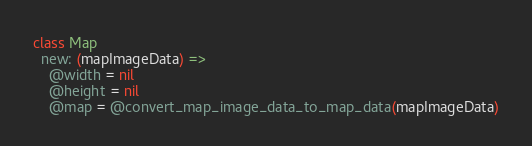Convert code to text. <code><loc_0><loc_0><loc_500><loc_500><_MoonScript_>class Map
  new: (mapImageData) =>
    @width = nil
    @height = nil
    @map = @convert_map_image_data_to_map_data(mapImageData)
</code> 